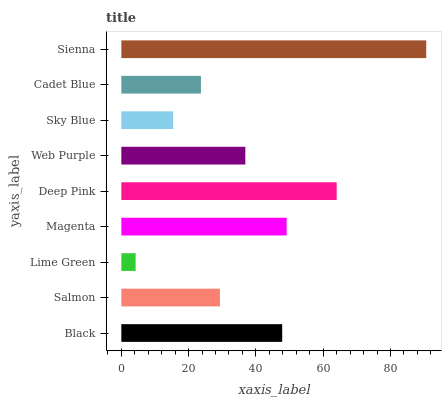Is Lime Green the minimum?
Answer yes or no. Yes. Is Sienna the maximum?
Answer yes or no. Yes. Is Salmon the minimum?
Answer yes or no. No. Is Salmon the maximum?
Answer yes or no. No. Is Black greater than Salmon?
Answer yes or no. Yes. Is Salmon less than Black?
Answer yes or no. Yes. Is Salmon greater than Black?
Answer yes or no. No. Is Black less than Salmon?
Answer yes or no. No. Is Web Purple the high median?
Answer yes or no. Yes. Is Web Purple the low median?
Answer yes or no. Yes. Is Deep Pink the high median?
Answer yes or no. No. Is Sky Blue the low median?
Answer yes or no. No. 